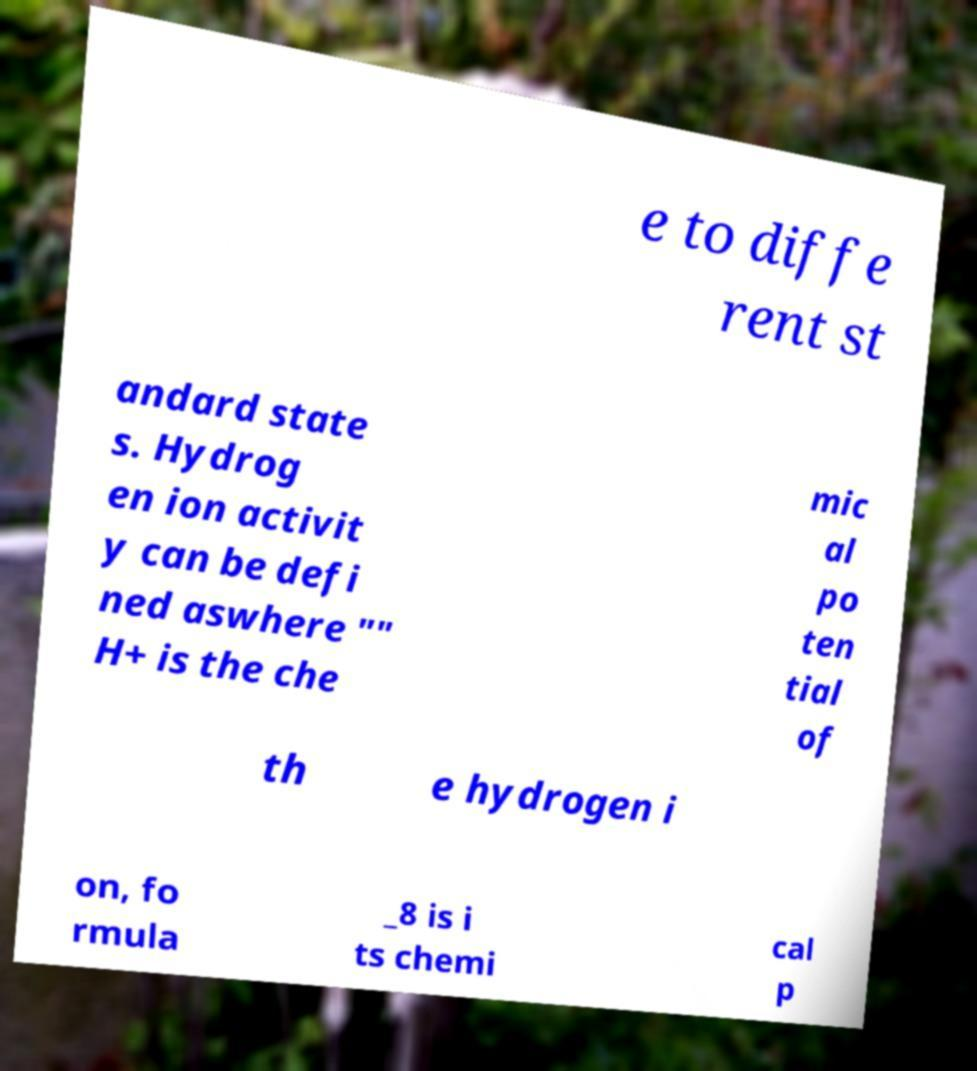Can you accurately transcribe the text from the provided image for me? e to diffe rent st andard state s. Hydrog en ion activit y can be defi ned aswhere "" H+ is the che mic al po ten tial of th e hydrogen i on, fo rmula _8 is i ts chemi cal p 